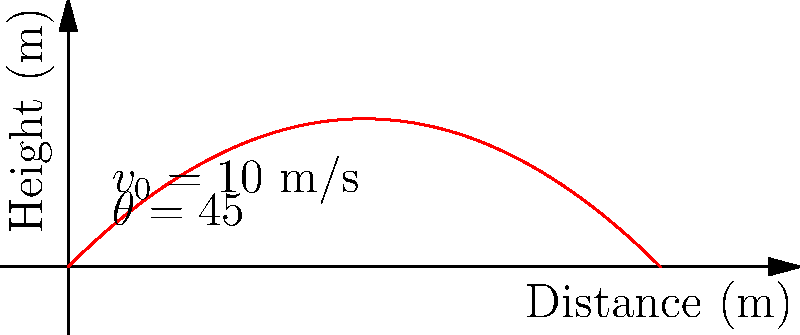In a BattleBots match, a robot is flipped into the air with an initial velocity of 10 m/s at a 45° angle. Assuming no air resistance, what is the maximum height reached by the robot during its trajectory? To solve this problem, we'll use the principles of projectile motion. Let's break it down step-by-step:

1) The maximum height is reached when the vertical velocity becomes zero. We can use the equation:

   $$v_y = v_0 \sin{\theta} - gt$$

   where $v_y$ is the vertical velocity, $v_0$ is the initial velocity, $\theta$ is the launch angle, $g$ is the acceleration due to gravity, and $t$ is the time.

2) At the highest point, $v_y = 0$. So:

   $$0 = v_0 \sin{\theta} - gt_{max}$$

3) Solve for $t_{max}$:

   $$t_{max} = \frac{v_0 \sin{\theta}}{g}$$

4) Substitute the given values:
   $v_0 = 10$ m/s, $\theta = 45°$, and $g = 9.8$ m/s²

   $$t_{max} = \frac{10 \sin{45°}}{9.8} = \frac{10 \cdot 0.707}{9.8} = 0.721 \text{ s}$$

5) Now use the equation for the height of a projectile:

   $$h = v_0 \sin{\theta} \cdot t - \frac{1}{2}gt^2$$

6) Substitute $t_{max}$ into this equation:

   $$h_{max} = v_0 \sin{\theta} \cdot (\frac{v_0 \sin{\theta}}{g}) - \frac{1}{2}g(\frac{v_0 \sin{\theta}}{g})^2$$

7) Simplify:

   $$h_{max} = \frac{v_0^2 \sin^2{\theta}}{g} - \frac{v_0^2 \sin^2{\theta}}{2g} = \frac{v_0^2 \sin^2{\theta}}{2g}$$

8) Substitute the values:

   $$h_{max} = \frac{10^2 \cdot \sin^2{45°}}{2 \cdot 9.8} = \frac{100 \cdot 0.5}{19.6} = 2.55 \text{ m}$$

Therefore, the maximum height reached by the robot is approximately 2.55 meters.
Answer: 2.55 m 